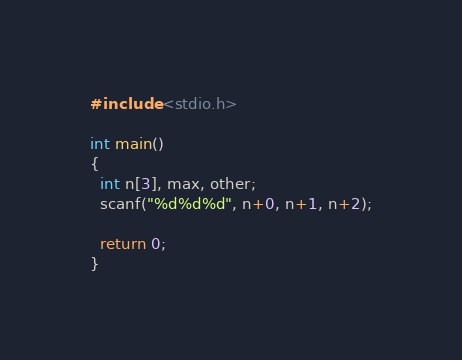<code> <loc_0><loc_0><loc_500><loc_500><_C_>#include <stdio.h>

int main()
{
  int n[3], max, other;
  scanf("%d%d%d", n+0, n+1, n+2);

  return 0;
}</code> 